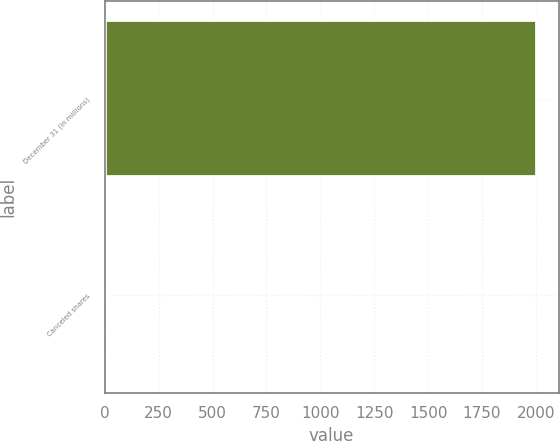Convert chart to OTSL. <chart><loc_0><loc_0><loc_500><loc_500><bar_chart><fcel>December 31 (in millions)<fcel>Canceled shares<nl><fcel>2005<fcel>2<nl></chart> 